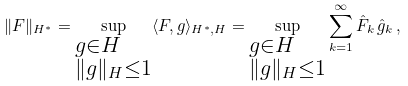<formula> <loc_0><loc_0><loc_500><loc_500>\| F \| _ { H ^ { * } } = \sup _ { \begin{subarray} { c } g \in H \\ \| g \| _ { H } \leq 1 \end{subarray} } \langle F , g \rangle _ { H ^ { * } , H } = \sup _ { \begin{subarray} { c } g \in H \\ \| g \| _ { H } \leq 1 \end{subarray} } \sum _ { k = 1 } ^ { \infty } \hat { F } _ { k } \, \hat { g } _ { k } \, ,</formula> 